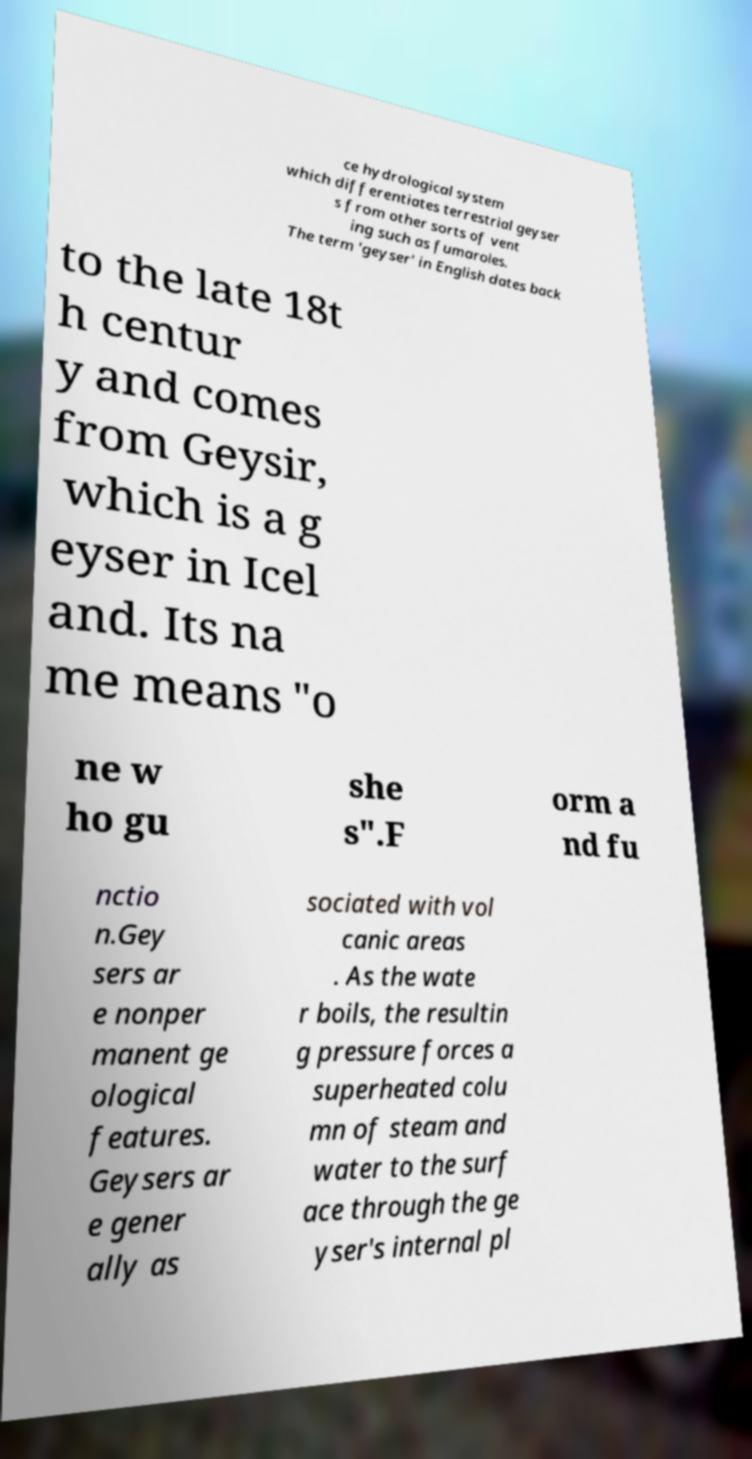Please read and relay the text visible in this image. What does it say? ce hydrological system which differentiates terrestrial geyser s from other sorts of vent ing such as fumaroles. The term 'geyser' in English dates back to the late 18t h centur y and comes from Geysir, which is a g eyser in Icel and. Its na me means "o ne w ho gu she s".F orm a nd fu nctio n.Gey sers ar e nonper manent ge ological features. Geysers ar e gener ally as sociated with vol canic areas . As the wate r boils, the resultin g pressure forces a superheated colu mn of steam and water to the surf ace through the ge yser's internal pl 